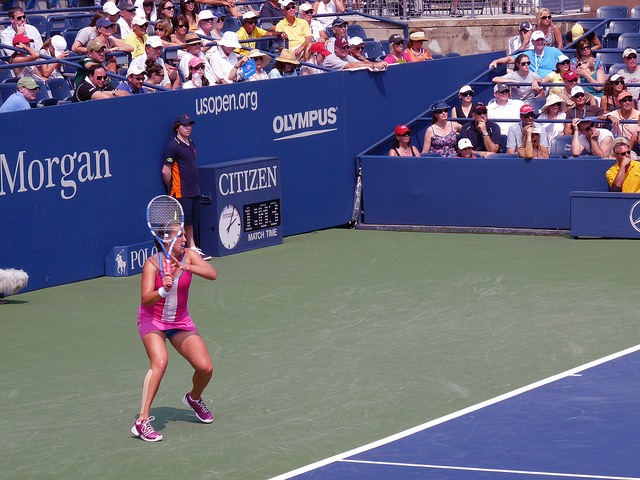Please extract the text content from this image. Morgan POLO CITIZEN MATCH TIME 1:03 OLYMPUS usopen.org 